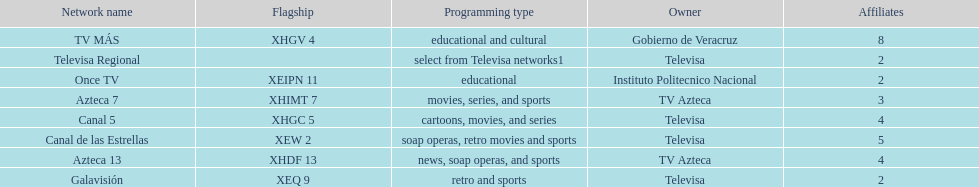What is the number of affiliates of canal de las estrellas. 5. 